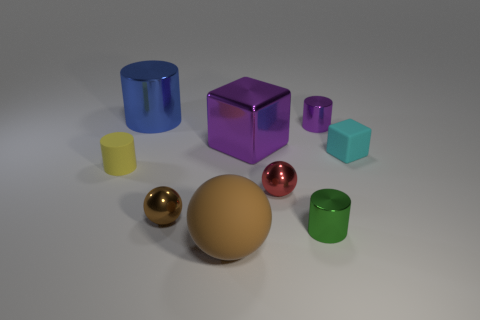Add 1 small cyan blocks. How many objects exist? 10 Subtract all spheres. How many objects are left? 6 Add 3 big matte balls. How many big matte balls exist? 4 Subtract 1 purple cylinders. How many objects are left? 8 Subtract all purple shiny cubes. Subtract all purple metal cylinders. How many objects are left? 7 Add 7 large things. How many large things are left? 10 